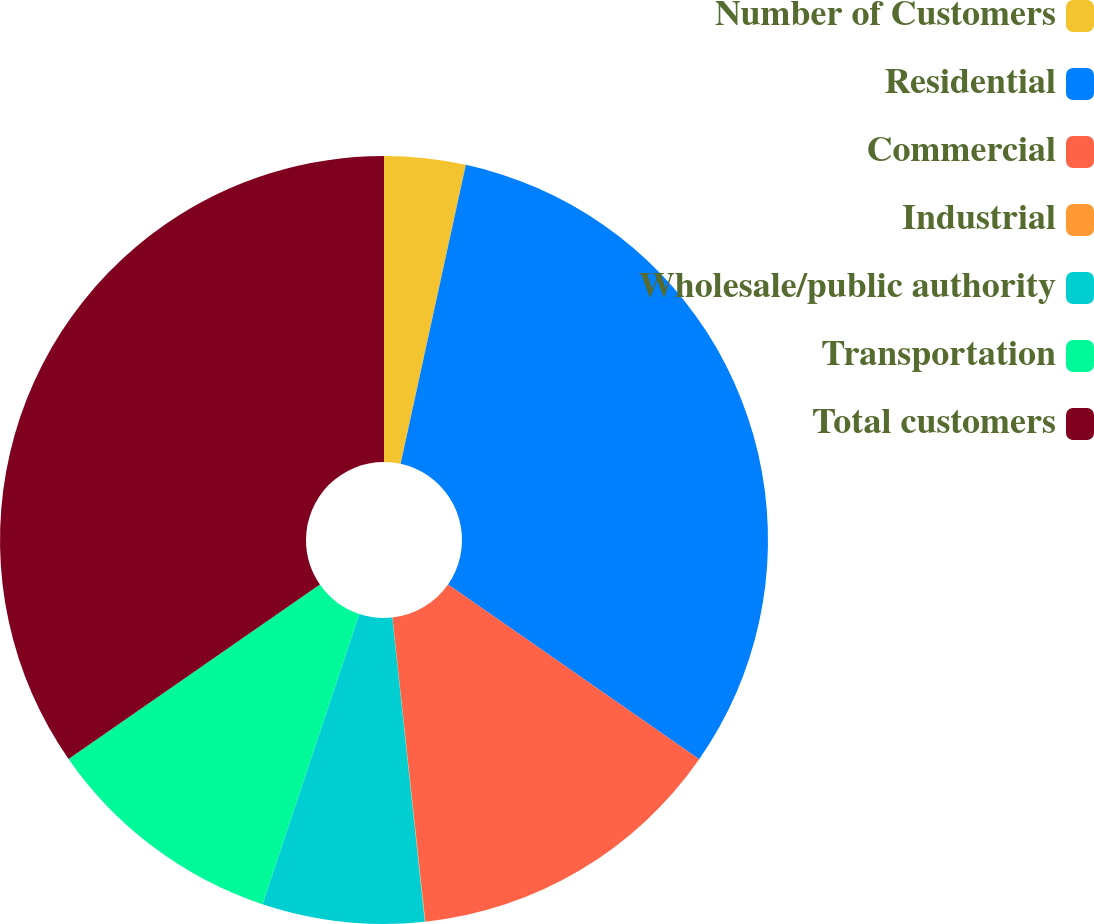Convert chart to OTSL. <chart><loc_0><loc_0><loc_500><loc_500><pie_chart><fcel>Number of Customers<fcel>Residential<fcel>Commercial<fcel>Industrial<fcel>Wholesale/public authority<fcel>Transportation<fcel>Total customers<nl><fcel>3.42%<fcel>31.26%<fcel>13.61%<fcel>0.02%<fcel>6.82%<fcel>10.22%<fcel>34.66%<nl></chart> 